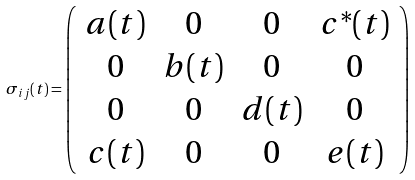<formula> <loc_0><loc_0><loc_500><loc_500>\sigma _ { i j } ( t ) = \left ( \begin{array} { c c c c } a ( t ) & 0 & 0 & c ^ { * } ( t ) \\ 0 & b ( t ) & 0 & 0 \\ 0 & 0 & d ( t ) & 0 \\ c ( t ) & 0 & 0 & e ( t ) \end{array} \right )</formula> 